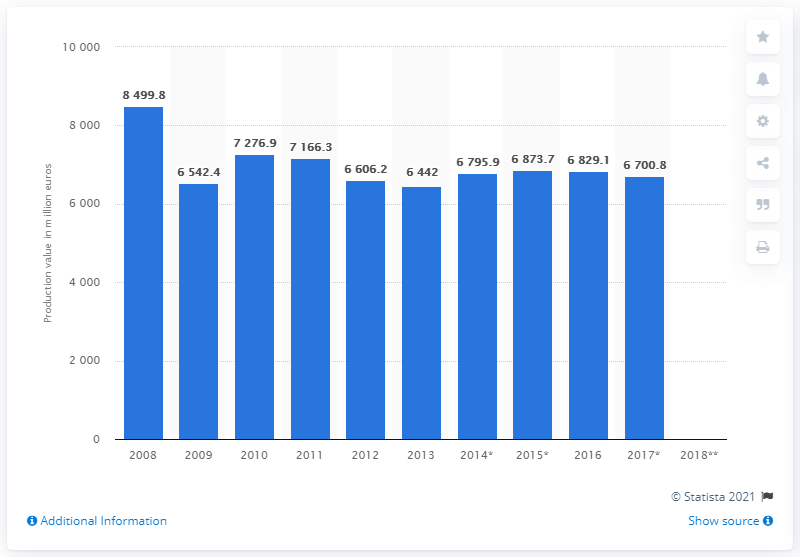Outline some significant characteristics in this image. In 2017, the production value of the French textile manufacturing sector was 6,700.8 million euros. 